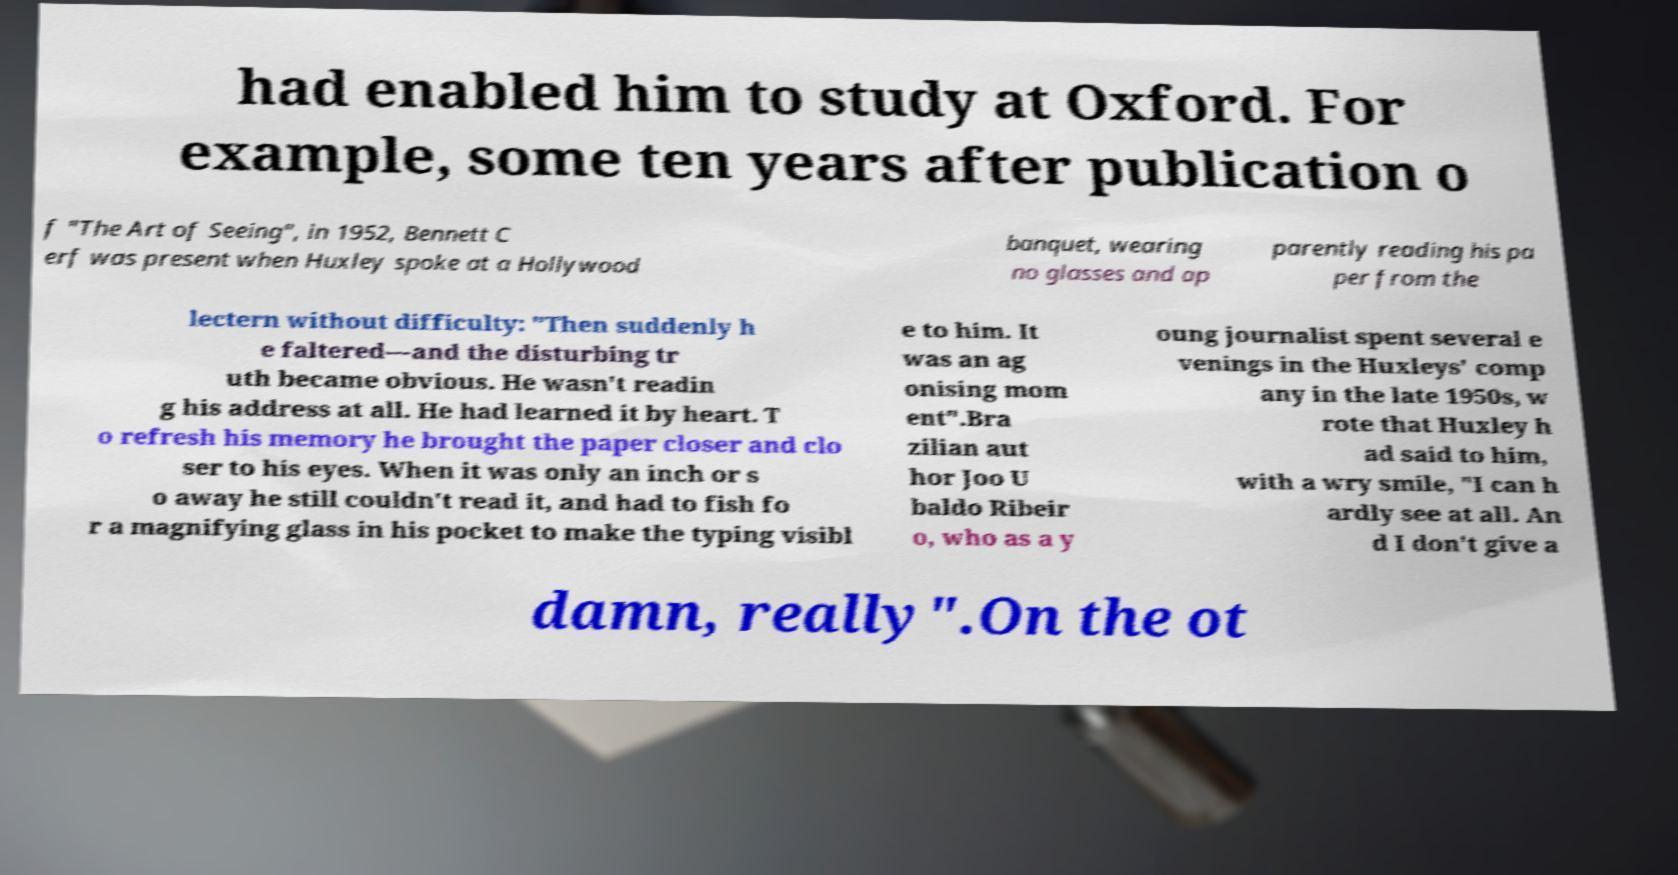What messages or text are displayed in this image? I need them in a readable, typed format. had enabled him to study at Oxford. For example, some ten years after publication o f "The Art of Seeing", in 1952, Bennett C erf was present when Huxley spoke at a Hollywood banquet, wearing no glasses and ap parently reading his pa per from the lectern without difficulty: "Then suddenly h e faltered—and the disturbing tr uth became obvious. He wasn't readin g his address at all. He had learned it by heart. T o refresh his memory he brought the paper closer and clo ser to his eyes. When it was only an inch or s o away he still couldn't read it, and had to fish fo r a magnifying glass in his pocket to make the typing visibl e to him. It was an ag onising mom ent".Bra zilian aut hor Joo U baldo Ribeir o, who as a y oung journalist spent several e venings in the Huxleys' comp any in the late 1950s, w rote that Huxley h ad said to him, with a wry smile, "I can h ardly see at all. An d I don't give a damn, really".On the ot 